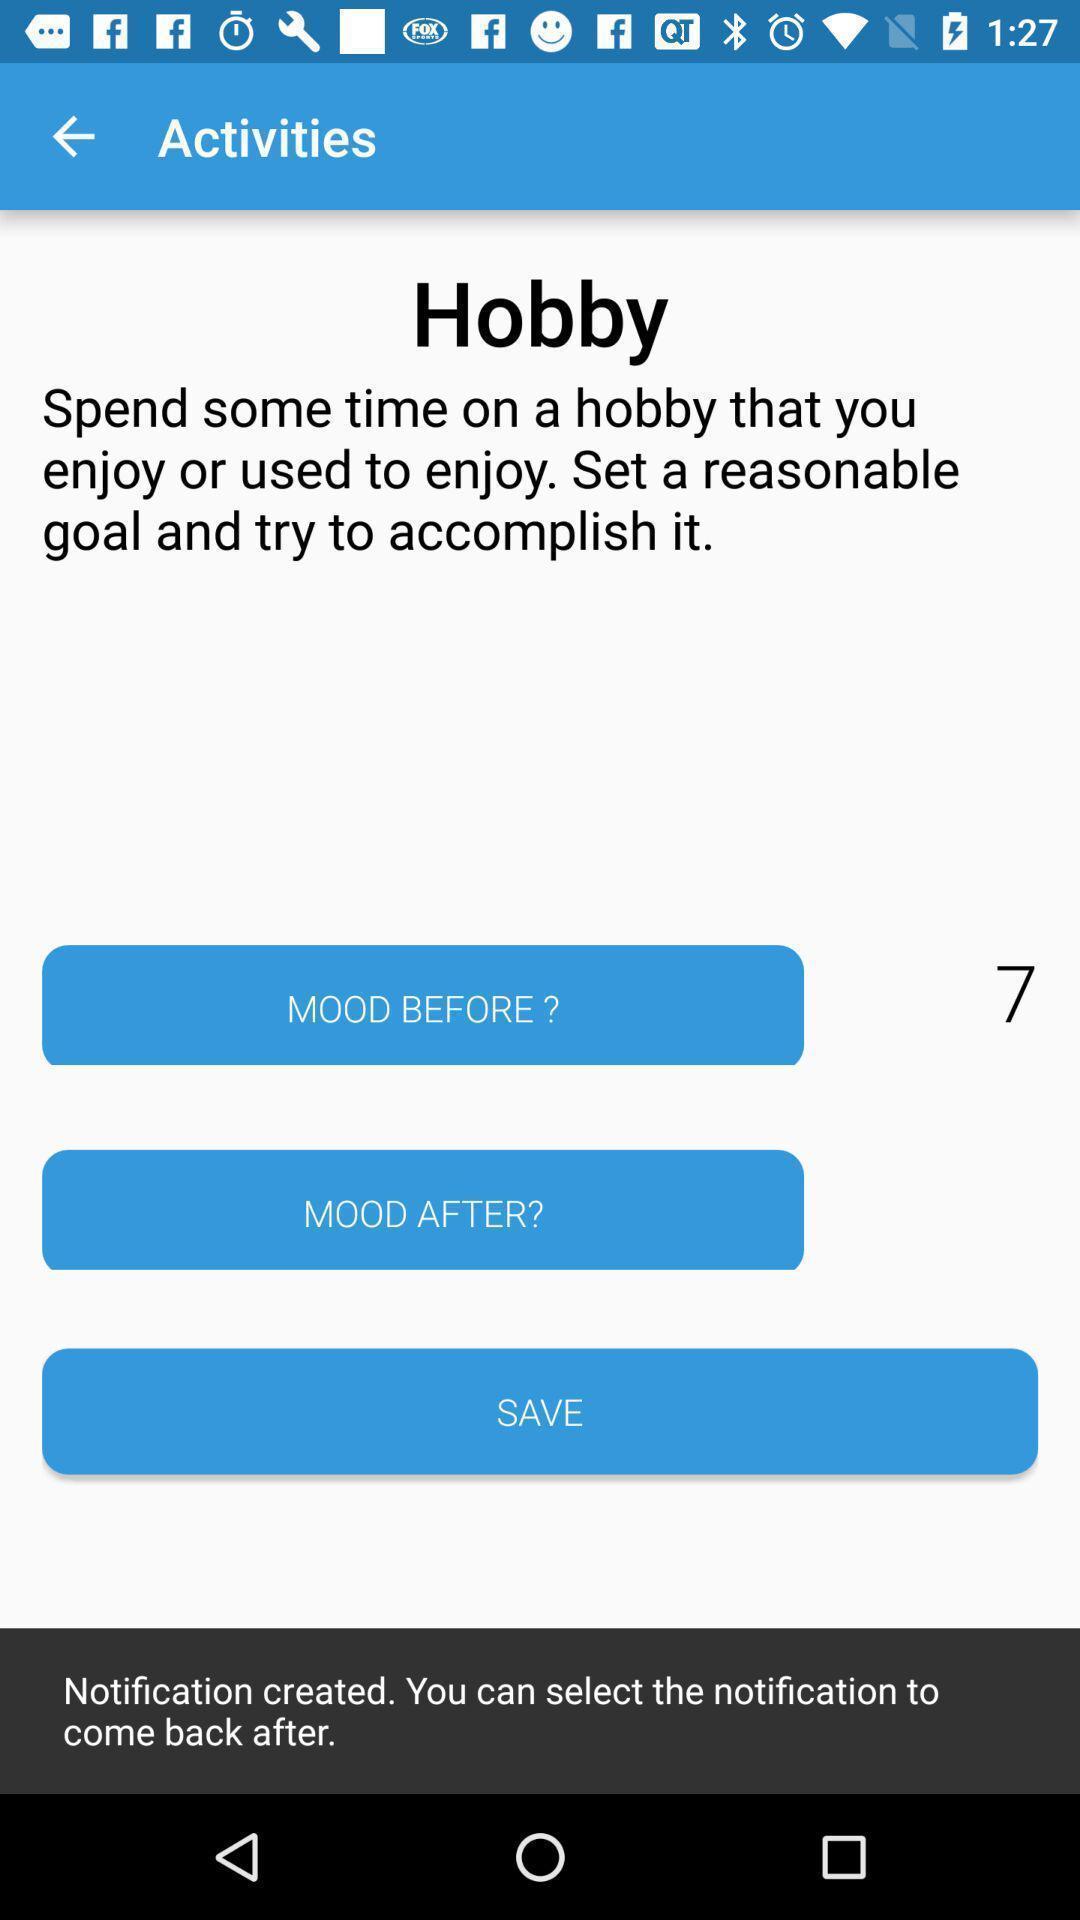What is the overall content of this screenshot? Various activity page displayed. 